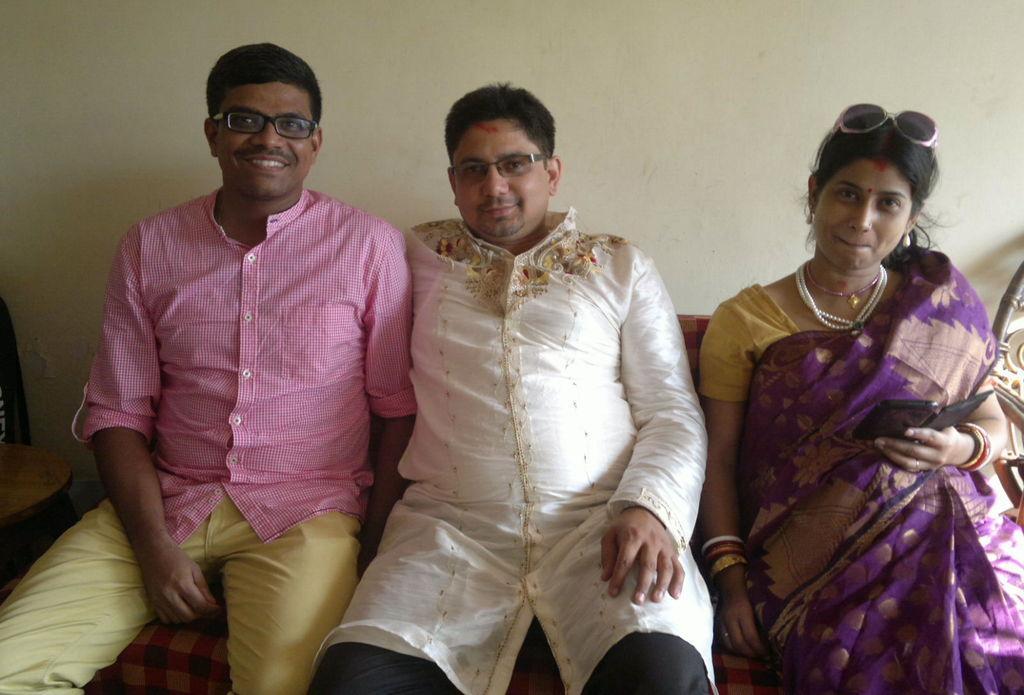In one or two sentences, can you explain what this image depicts? There are people sitting in the foreground area of the image and a chair on the left side, there is a wall in the background. 